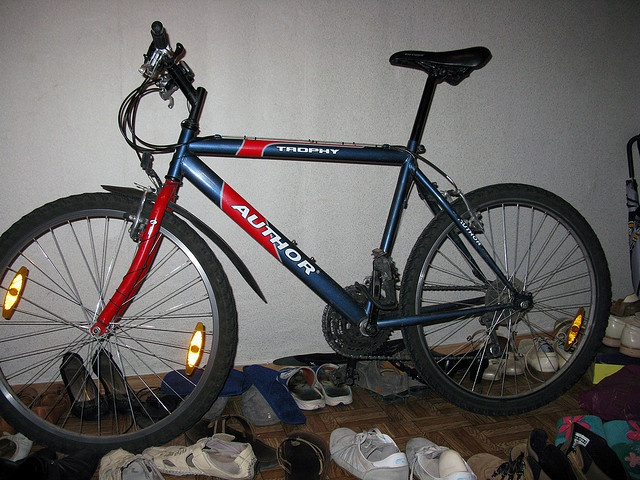Describe the objects in this image and their specific colors. I can see bicycle in gray, black, darkgray, and lightgray tones and umbrella in gray and black tones in this image. 